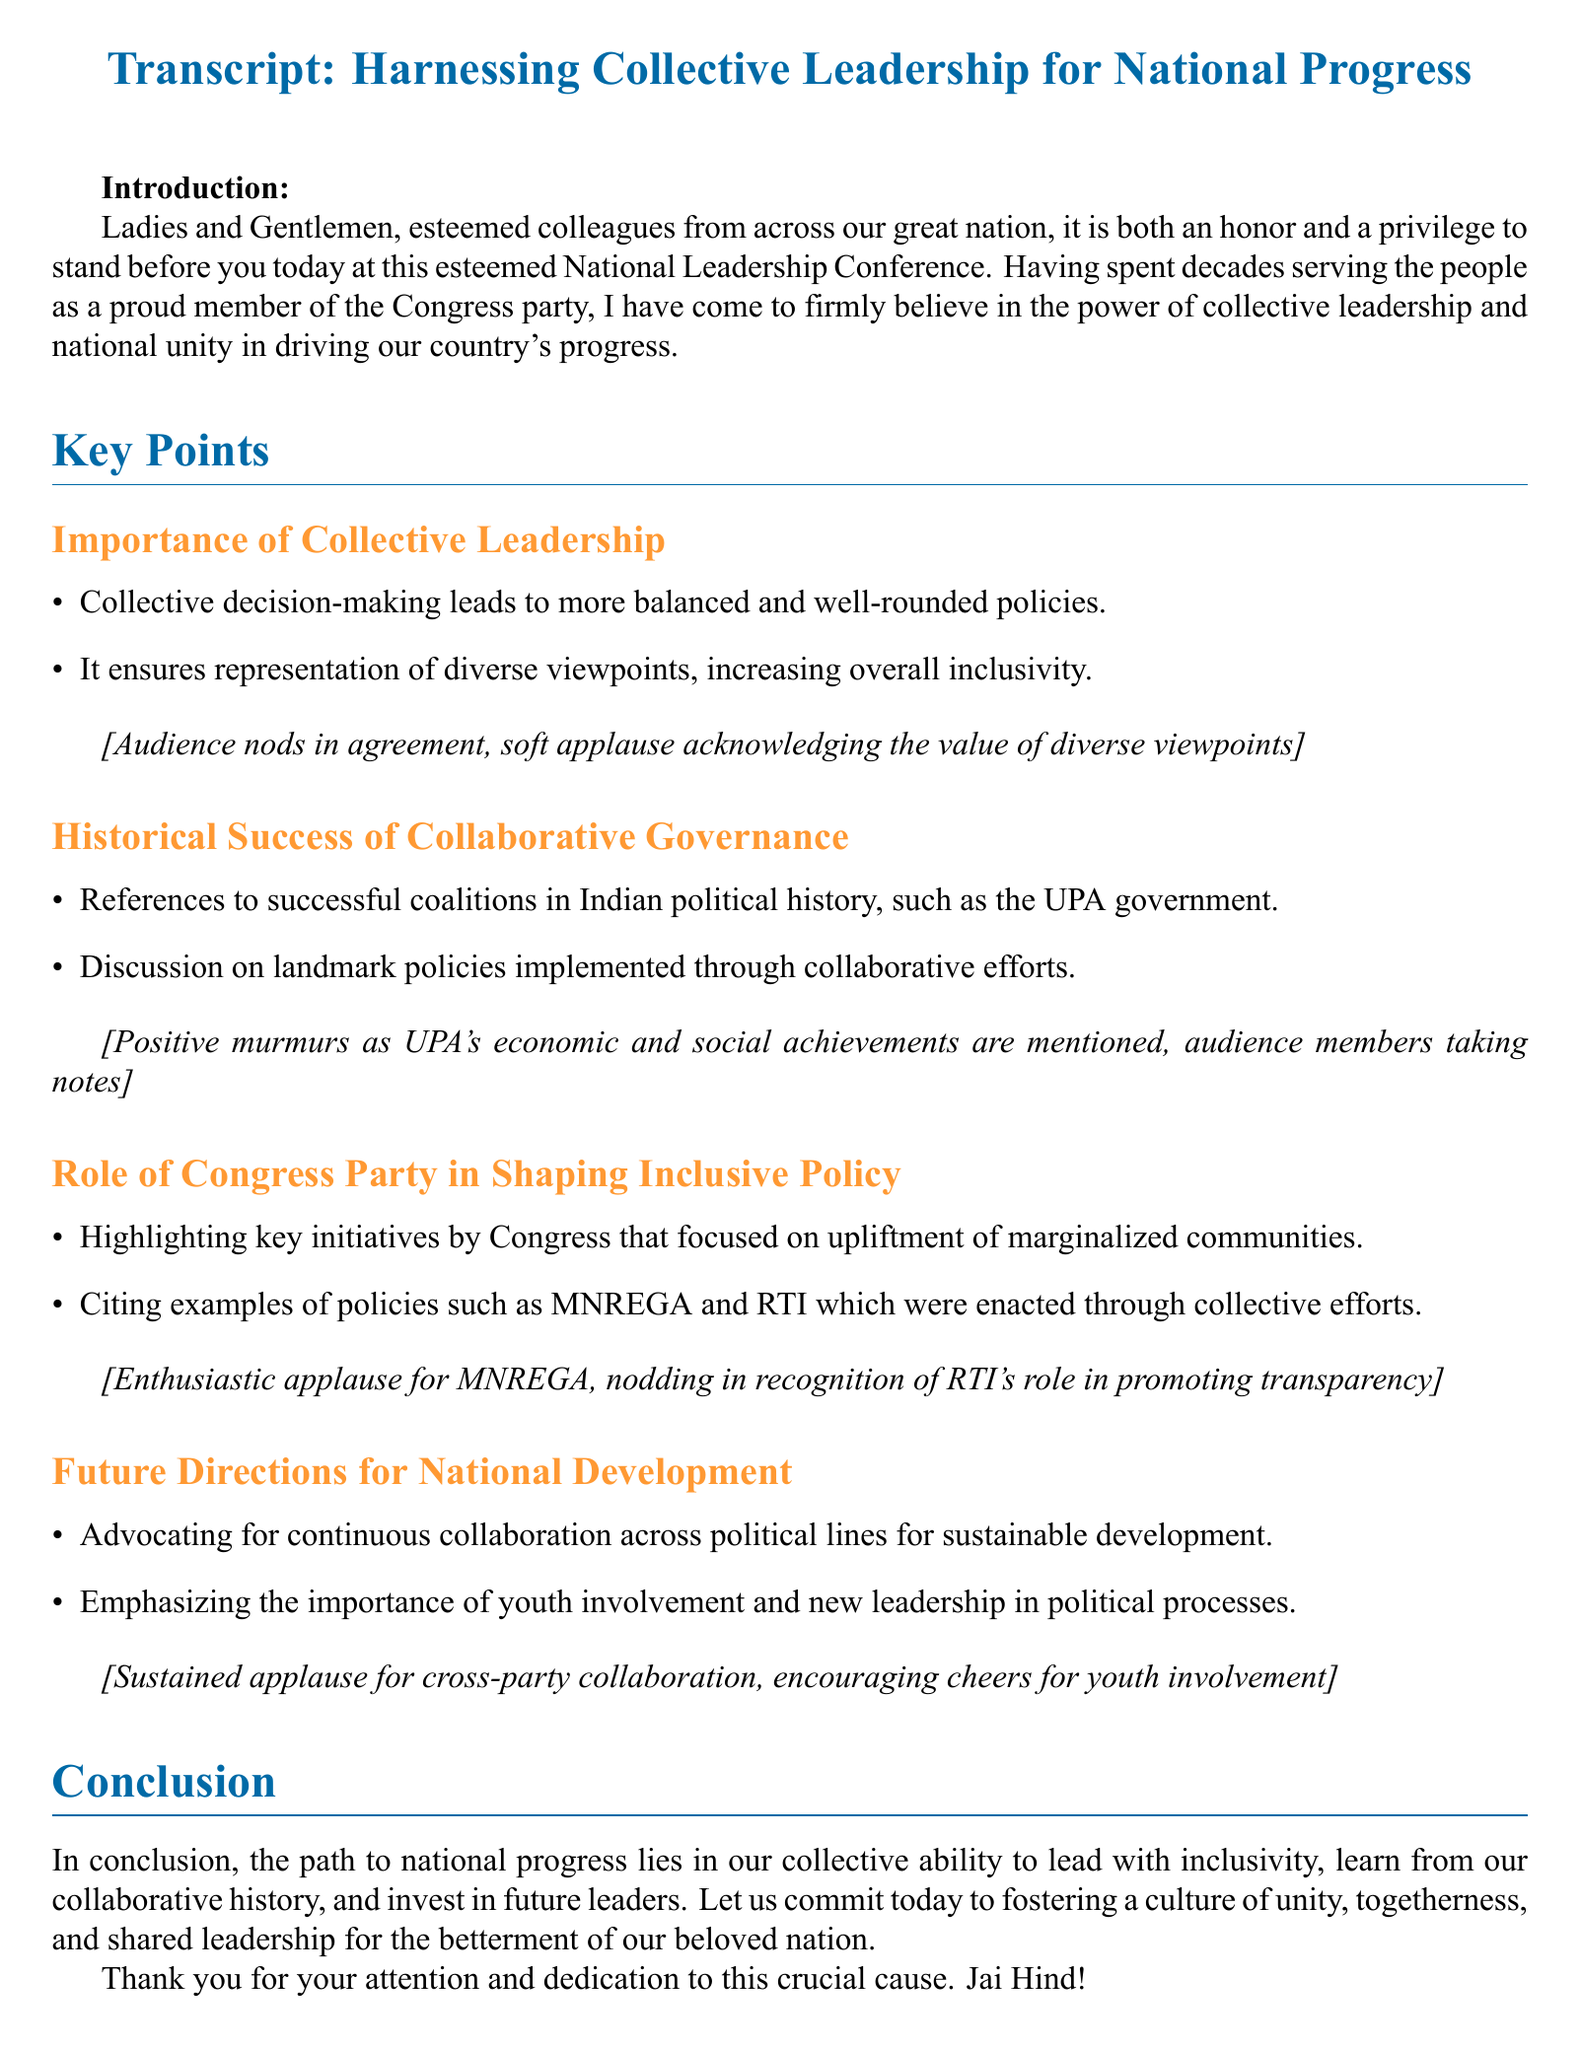What is the title of the speech? The title of the speech is indicated at the beginning of the document, which is "Harnessing Collective Leadership for National Progress."
Answer: Harnessing Collective Leadership for National Progress What are the main themes of the speech? The main themes include collective leadership, historical success of collaborative governance, the role of the Congress party, and future directions for national development.
Answer: Collective leadership, collaborative governance, Congress party's role, future development Which important policy initiatives were highlighted? The speech mentions key initiatives such as MNREGA and RTI, emphasizing their significance in uplifting marginalized communities.
Answer: MNREGA and RTI What audience reaction followed the mention of MNREGA? After mentioning MNREGA, the audience reacted with enthusiastic applause, showing strong approval for the initiative.
Answer: Enthusiastic applause How does the speaker suggest fostering future leadership? The speaker emphasizes the importance of youth involvement and new leadership in the political processes for sustainable development.
Answer: Youth involvement and new leadership What was the overall tone of the audience towards the discussion of historical successes? The audience exhibited positive murmurs and engaged reactions when successful coalitions like the UPA government were referenced.
Answer: Positive murmurs What does the speaker conclude about national progress? The speaker concludes that national progress relies on collective ability to lead with inclusivity and shared leadership.
Answer: Collective ability to lead with inclusivity How many sections are there in the speech? The speech is divided into five main sections, including the introduction, key points, and conclusion.
Answer: Five sections What is the color theme used in the document? The document uses a color theme consisting of congress blue and congress orange, as mentioned in the formatting instructions.
Answer: Congress blue and congress orange 